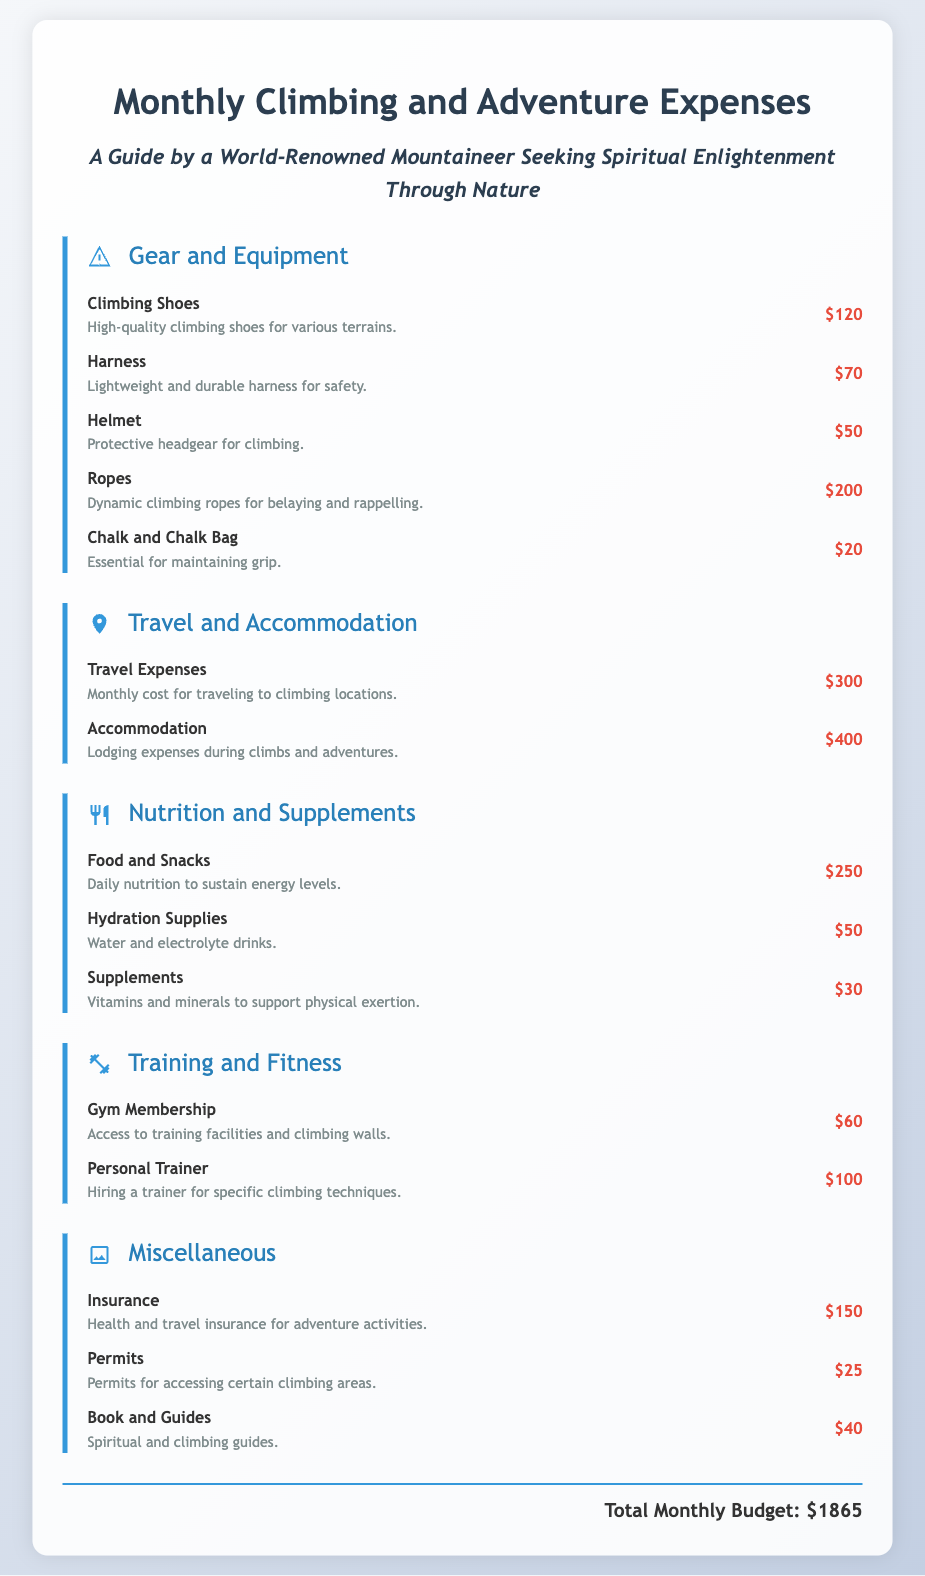what is the total monthly budget? The total monthly budget is mentioned at the bottom of the document and includes all expenses.
Answer: $1865 how much do climbing shoes cost? The cost for climbing shoes can be found in the Gear and Equipment section.
Answer: $120 which item is related to protective headgear? The item related to protective headgear is listed under Gear and Equipment.
Answer: Helmet what is the cost for accommodation? Accommodation expenses are listed in the Travel and Accommodation section.
Answer: $400 how much is spent on nutrition and supplements? The total for nutrition and supplements can be calculated by adding individual costs in that section.
Answer: $330 what percentage of the total budget goes to travel expenses? Travel expenses are a portion of the total monthly budget and can be calculated in relation to it.
Answer: 16% how many items are listed under Miscellaneous? The number of items listed in the Miscellaneous section reflects the different categories of expenses.
Answer: 3 which gear's cost is the highest? The highest cost among the gear items can be identified through the Gear and Equipment section.
Answer: Ropes what is the purpose of the items under the Training and Fitness section? The items in the Training and Fitness section serve specific purposes to enhance climbing abilities.
Answer: Fitness training 